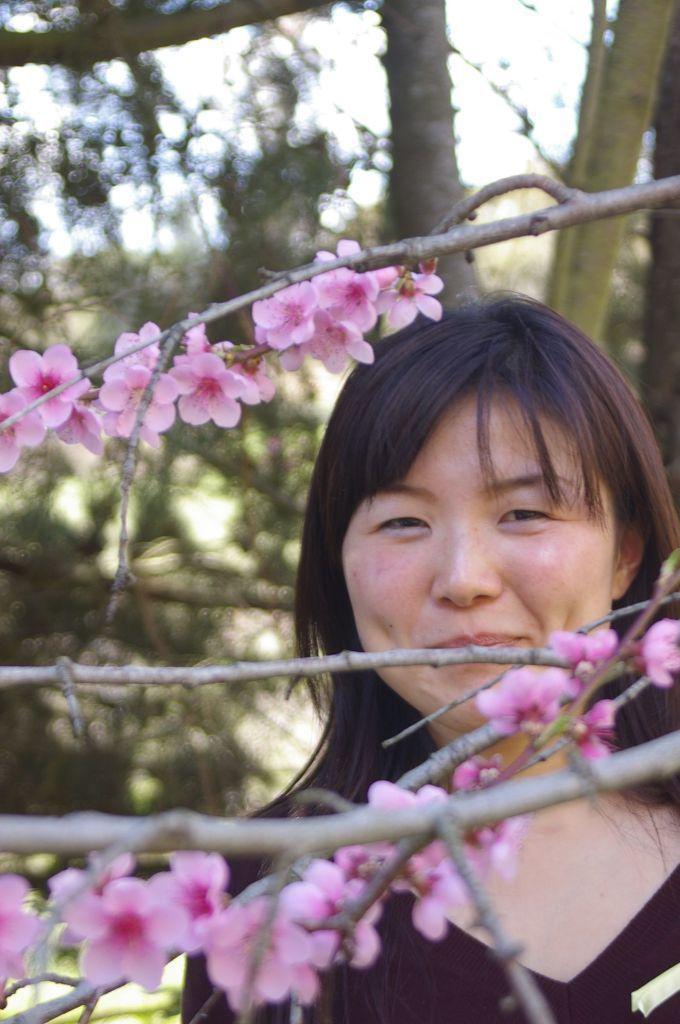Describe this image in one or two sentences. In the foreground of the picture we can see flowers, stems and woman. In the background there are trees and sky. 